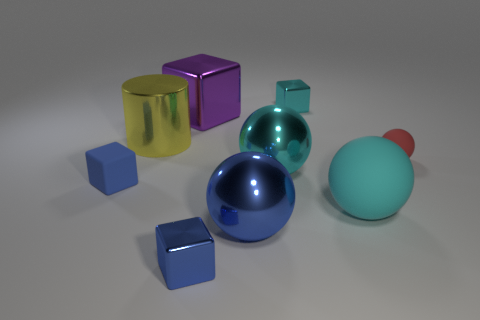What is the shape of the blue metal thing that is the same size as the red sphere?
Provide a short and direct response. Cube. There is a tiny rubber object that is to the right of the blue metallic thing on the right side of the metallic cube that is in front of the red rubber sphere; what is its shape?
Make the answer very short. Sphere. Are there the same number of purple metallic things that are behind the large purple cube and matte spheres?
Keep it short and to the point. No. Do the red object and the yellow thing have the same size?
Your response must be concise. No. How many matte objects are yellow objects or small cyan blocks?
Give a very brief answer. 0. What material is the cyan object that is the same size as the red matte ball?
Your response must be concise. Metal. How many other things are made of the same material as the red sphere?
Your answer should be very brief. 2. Are there fewer yellow objects that are on the right side of the big yellow shiny thing than big purple metallic cylinders?
Your response must be concise. No. Do the large blue thing and the red thing have the same shape?
Give a very brief answer. Yes. There is a blue thing behind the large blue metal ball in front of the blue thing that is behind the big blue metallic sphere; what is its size?
Keep it short and to the point. Small. 